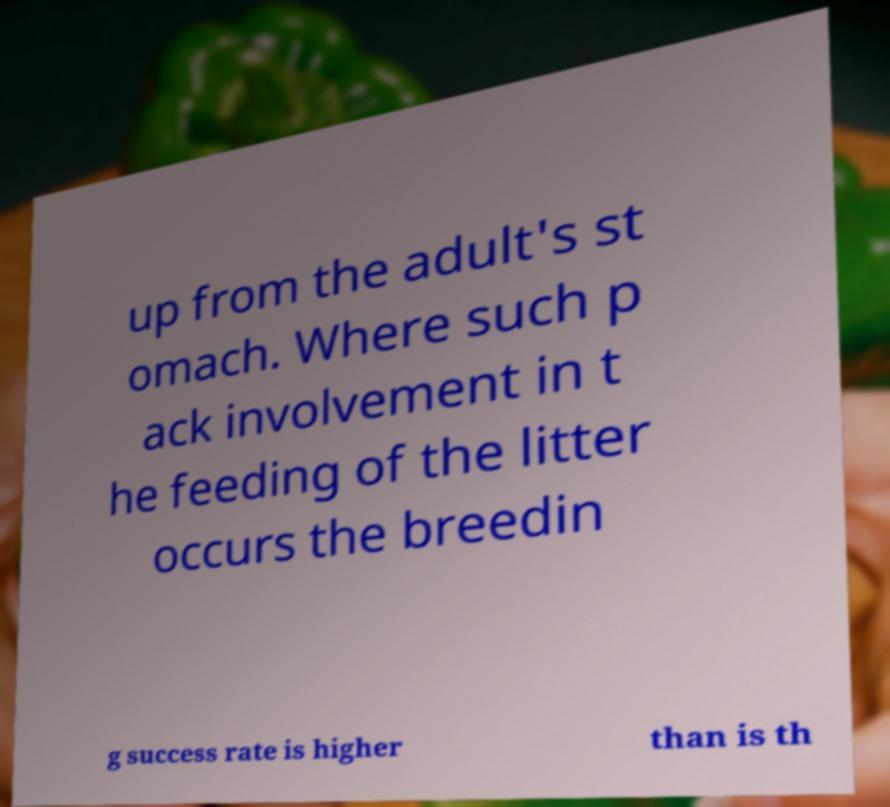Can you read and provide the text displayed in the image?This photo seems to have some interesting text. Can you extract and type it out for me? up from the adult's st omach. Where such p ack involvement in t he feeding of the litter occurs the breedin g success rate is higher than is th 